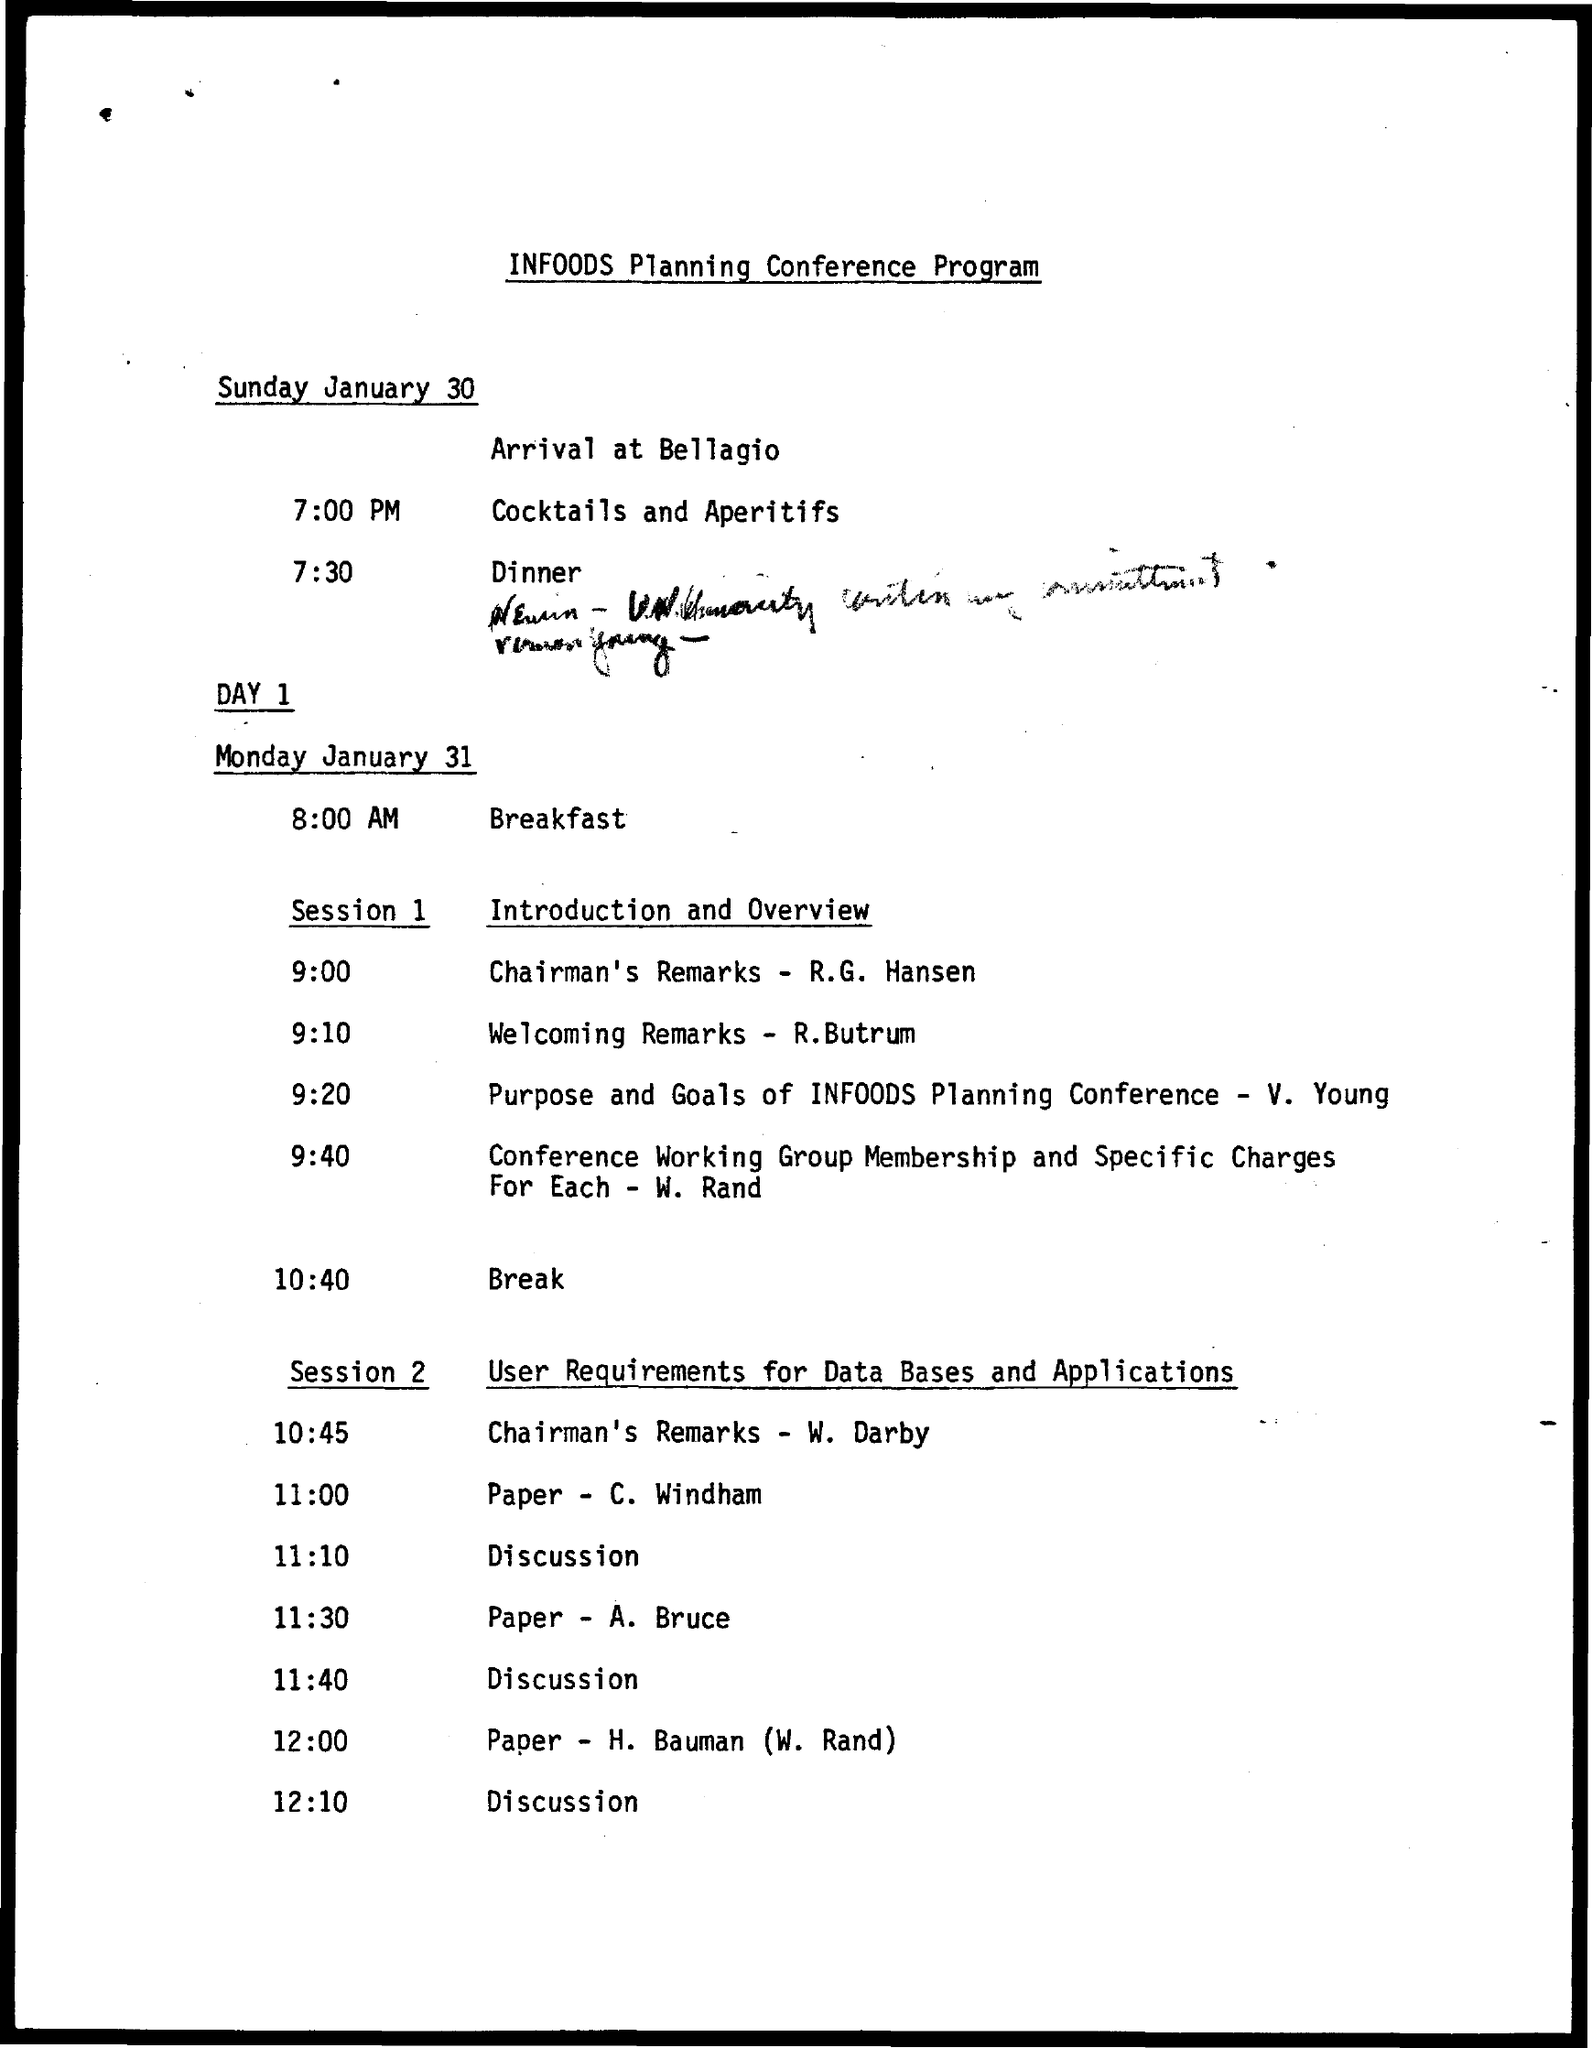What time is the welcoming remarks presented by R.Butrum?
Your answer should be very brief. 9:10. Who is presenting the purpose and goals of INFOODS planning conference?
Your response must be concise. V. Young. What time is the dinner scheduled on sunday january 30?
Provide a succinct answer. 7:30. Who is presenting Chairman's remarks in session 2?
Your answer should be compact. W. Darby. What time is the paper presentation by A. Bruce scheduled?
Make the answer very short. 11:30. What is the date of arrival at Bellagio?
Your answer should be compact. Sunday January 30. Who is presenting Chairman's remarks in session 1?
Ensure brevity in your answer.  R.G. Hansen. What time is the paper presentation by C. Windham scheduled during session 2?
Your answer should be very brief. 11:00. 